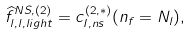<formula> <loc_0><loc_0><loc_500><loc_500>\widehat { f } _ { l , l , l i g h t } ^ { N S , ( 2 ) } = c _ { I , n s } ^ { ( 2 , * ) } ( n _ { f } = N _ { l } ) ,</formula> 